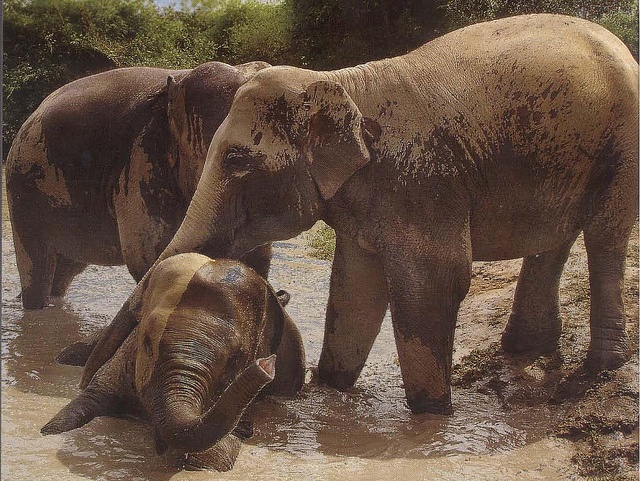Describe the objects in this image and their specific colors. I can see elephant in gray, maroon, and black tones, elephant in gray, black, brown, and maroon tones, and elephant in gray, maroon, and black tones in this image. 